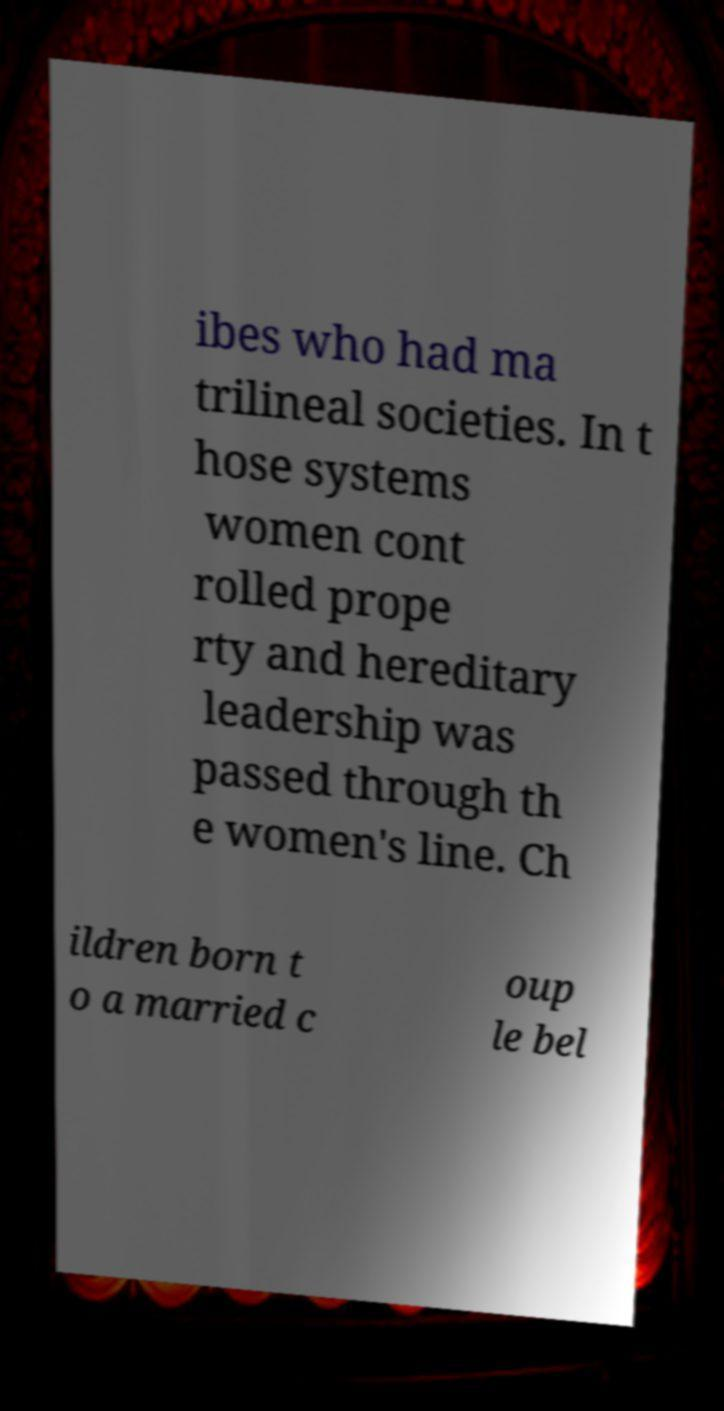Could you extract and type out the text from this image? ibes who had ma trilineal societies. In t hose systems women cont rolled prope rty and hereditary leadership was passed through th e women's line. Ch ildren born t o a married c oup le bel 